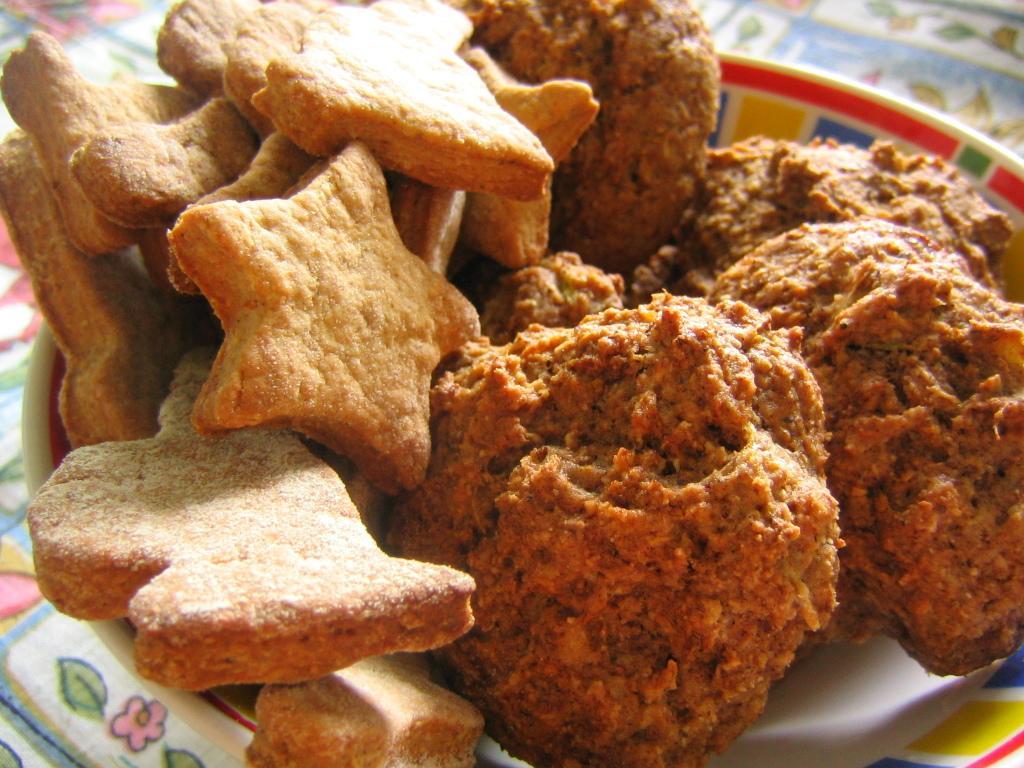In one or two sentences, can you explain what this image depicts? In this image there are food items placed in a bowl, which is on the table. 